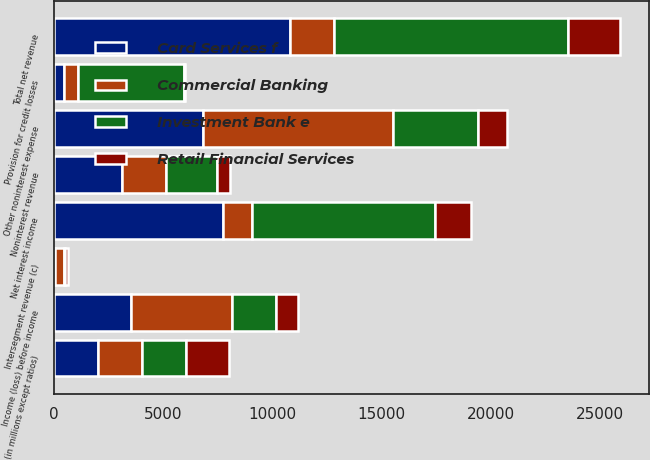Convert chart to OTSL. <chart><loc_0><loc_0><loc_500><loc_500><stacked_bar_chart><ecel><fcel>(in millions except ratios)<fcel>Net interest income<fcel>Noninterest revenue<fcel>Intersegment revenue (c)<fcel>Total net revenue<fcel>Provision for credit losses<fcel>Other noninterest expense<fcel>Income (loss) before income<nl><fcel>Commercial Banking<fcel>2004<fcel>1325<fcel>2004<fcel>425<fcel>2004<fcel>640<fcel>8696<fcel>4639<nl><fcel>Card Services f<fcel>2004<fcel>7714<fcel>3119<fcel>42<fcel>10791<fcel>449<fcel>6825<fcel>3517<nl><fcel>Investment Bank e<fcel>2004<fcel>8374<fcel>2349<fcel>22<fcel>10745<fcel>4851<fcel>3883<fcel>2011<nl><fcel>Retail Financial Services<fcel>2004<fcel>1692<fcel>561<fcel>121<fcel>2374<fcel>41<fcel>1343<fcel>990<nl></chart> 